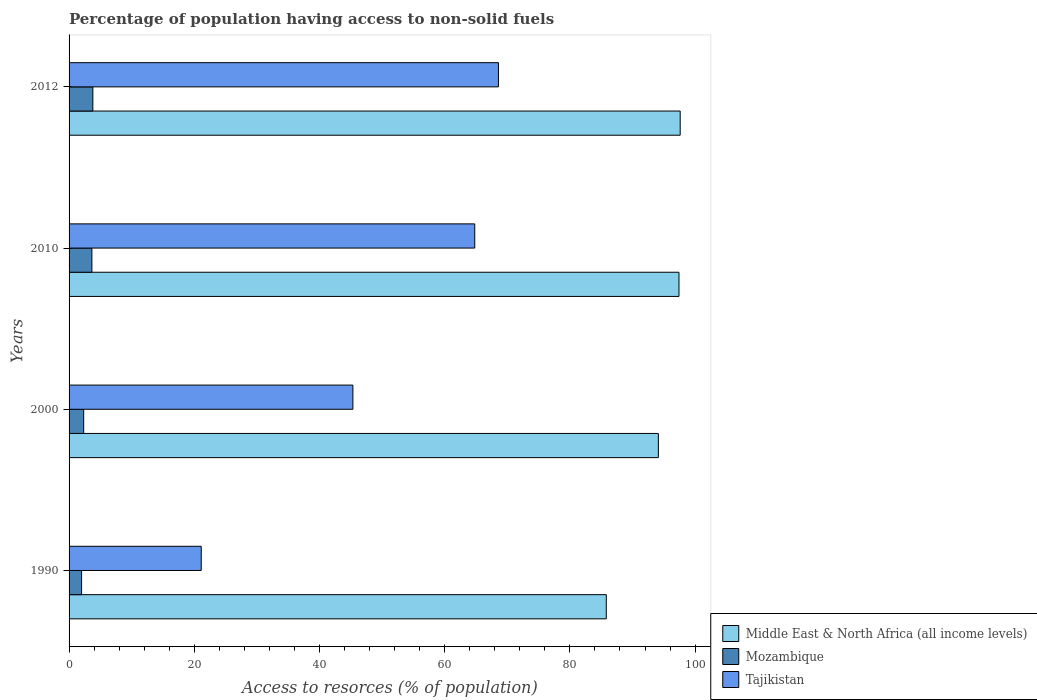How many groups of bars are there?
Ensure brevity in your answer.  4. What is the percentage of population having access to non-solid fuels in Mozambique in 1990?
Ensure brevity in your answer.  2. Across all years, what is the maximum percentage of population having access to non-solid fuels in Mozambique?
Ensure brevity in your answer.  3.8. Across all years, what is the minimum percentage of population having access to non-solid fuels in Mozambique?
Give a very brief answer. 2. What is the total percentage of population having access to non-solid fuels in Tajikistan in the graph?
Your answer should be compact. 199.84. What is the difference between the percentage of population having access to non-solid fuels in Middle East & North Africa (all income levels) in 1990 and that in 2000?
Your answer should be compact. -8.32. What is the difference between the percentage of population having access to non-solid fuels in Tajikistan in 2000 and the percentage of population having access to non-solid fuels in Middle East & North Africa (all income levels) in 2012?
Keep it short and to the point. -52.28. What is the average percentage of population having access to non-solid fuels in Mozambique per year?
Offer a terse response. 2.94. In the year 2010, what is the difference between the percentage of population having access to non-solid fuels in Tajikistan and percentage of population having access to non-solid fuels in Middle East & North Africa (all income levels)?
Make the answer very short. -32.62. What is the ratio of the percentage of population having access to non-solid fuels in Middle East & North Africa (all income levels) in 1990 to that in 2010?
Make the answer very short. 0.88. Is the percentage of population having access to non-solid fuels in Mozambique in 2000 less than that in 2010?
Your response must be concise. Yes. What is the difference between the highest and the second highest percentage of population having access to non-solid fuels in Middle East & North Africa (all income levels)?
Provide a succinct answer. 0.19. What is the difference between the highest and the lowest percentage of population having access to non-solid fuels in Mozambique?
Your response must be concise. 1.8. In how many years, is the percentage of population having access to non-solid fuels in Tajikistan greater than the average percentage of population having access to non-solid fuels in Tajikistan taken over all years?
Provide a short and direct response. 2. What does the 1st bar from the top in 2010 represents?
Your response must be concise. Tajikistan. What does the 3rd bar from the bottom in 1990 represents?
Give a very brief answer. Tajikistan. Is it the case that in every year, the sum of the percentage of population having access to non-solid fuels in Middle East & North Africa (all income levels) and percentage of population having access to non-solid fuels in Tajikistan is greater than the percentage of population having access to non-solid fuels in Mozambique?
Make the answer very short. Yes. How many bars are there?
Provide a succinct answer. 12. How many years are there in the graph?
Your response must be concise. 4. What is the difference between two consecutive major ticks on the X-axis?
Provide a short and direct response. 20. Does the graph contain grids?
Your answer should be very brief. No. Where does the legend appear in the graph?
Provide a short and direct response. Bottom right. How many legend labels are there?
Your response must be concise. 3. What is the title of the graph?
Your answer should be very brief. Percentage of population having access to non-solid fuels. What is the label or title of the X-axis?
Provide a short and direct response. Access to resorces (% of population). What is the Access to resorces (% of population) of Middle East & North Africa (all income levels) in 1990?
Your answer should be compact. 85.81. What is the Access to resorces (% of population) in Mozambique in 1990?
Your response must be concise. 2. What is the Access to resorces (% of population) of Tajikistan in 1990?
Give a very brief answer. 21.11. What is the Access to resorces (% of population) of Middle East & North Africa (all income levels) in 2000?
Give a very brief answer. 94.13. What is the Access to resorces (% of population) of Mozambique in 2000?
Your answer should be very brief. 2.34. What is the Access to resorces (% of population) in Tajikistan in 2000?
Your response must be concise. 45.34. What is the Access to resorces (% of population) of Middle East & North Africa (all income levels) in 2010?
Your answer should be compact. 97.43. What is the Access to resorces (% of population) of Mozambique in 2010?
Your answer should be very brief. 3.65. What is the Access to resorces (% of population) in Tajikistan in 2010?
Keep it short and to the point. 64.8. What is the Access to resorces (% of population) in Middle East & North Africa (all income levels) in 2012?
Keep it short and to the point. 97.62. What is the Access to resorces (% of population) in Mozambique in 2012?
Provide a succinct answer. 3.8. What is the Access to resorces (% of population) in Tajikistan in 2012?
Give a very brief answer. 68.59. Across all years, what is the maximum Access to resorces (% of population) of Middle East & North Africa (all income levels)?
Keep it short and to the point. 97.62. Across all years, what is the maximum Access to resorces (% of population) in Mozambique?
Keep it short and to the point. 3.8. Across all years, what is the maximum Access to resorces (% of population) in Tajikistan?
Keep it short and to the point. 68.59. Across all years, what is the minimum Access to resorces (% of population) in Middle East & North Africa (all income levels)?
Offer a terse response. 85.81. Across all years, what is the minimum Access to resorces (% of population) of Mozambique?
Ensure brevity in your answer.  2. Across all years, what is the minimum Access to resorces (% of population) of Tajikistan?
Offer a very short reply. 21.11. What is the total Access to resorces (% of population) in Middle East & North Africa (all income levels) in the graph?
Keep it short and to the point. 374.99. What is the total Access to resorces (% of population) in Mozambique in the graph?
Provide a short and direct response. 11.78. What is the total Access to resorces (% of population) in Tajikistan in the graph?
Give a very brief answer. 199.84. What is the difference between the Access to resorces (% of population) of Middle East & North Africa (all income levels) in 1990 and that in 2000?
Your response must be concise. -8.32. What is the difference between the Access to resorces (% of population) in Mozambique in 1990 and that in 2000?
Offer a very short reply. -0.34. What is the difference between the Access to resorces (% of population) in Tajikistan in 1990 and that in 2000?
Provide a succinct answer. -24.22. What is the difference between the Access to resorces (% of population) of Middle East & North Africa (all income levels) in 1990 and that in 2010?
Your answer should be compact. -11.61. What is the difference between the Access to resorces (% of population) of Mozambique in 1990 and that in 2010?
Provide a short and direct response. -1.65. What is the difference between the Access to resorces (% of population) of Tajikistan in 1990 and that in 2010?
Your response must be concise. -43.69. What is the difference between the Access to resorces (% of population) in Middle East & North Africa (all income levels) in 1990 and that in 2012?
Your response must be concise. -11.8. What is the difference between the Access to resorces (% of population) in Mozambique in 1990 and that in 2012?
Offer a very short reply. -1.8. What is the difference between the Access to resorces (% of population) in Tajikistan in 1990 and that in 2012?
Offer a very short reply. -47.47. What is the difference between the Access to resorces (% of population) of Middle East & North Africa (all income levels) in 2000 and that in 2010?
Make the answer very short. -3.3. What is the difference between the Access to resorces (% of population) in Mozambique in 2000 and that in 2010?
Give a very brief answer. -1.31. What is the difference between the Access to resorces (% of population) in Tajikistan in 2000 and that in 2010?
Provide a short and direct response. -19.47. What is the difference between the Access to resorces (% of population) in Middle East & North Africa (all income levels) in 2000 and that in 2012?
Make the answer very short. -3.49. What is the difference between the Access to resorces (% of population) in Mozambique in 2000 and that in 2012?
Your answer should be compact. -1.46. What is the difference between the Access to resorces (% of population) of Tajikistan in 2000 and that in 2012?
Your answer should be compact. -23.25. What is the difference between the Access to resorces (% of population) of Middle East & North Africa (all income levels) in 2010 and that in 2012?
Ensure brevity in your answer.  -0.19. What is the difference between the Access to resorces (% of population) of Mozambique in 2010 and that in 2012?
Offer a terse response. -0.15. What is the difference between the Access to resorces (% of population) in Tajikistan in 2010 and that in 2012?
Keep it short and to the point. -3.78. What is the difference between the Access to resorces (% of population) of Middle East & North Africa (all income levels) in 1990 and the Access to resorces (% of population) of Mozambique in 2000?
Offer a very short reply. 83.48. What is the difference between the Access to resorces (% of population) in Middle East & North Africa (all income levels) in 1990 and the Access to resorces (% of population) in Tajikistan in 2000?
Ensure brevity in your answer.  40.48. What is the difference between the Access to resorces (% of population) in Mozambique in 1990 and the Access to resorces (% of population) in Tajikistan in 2000?
Provide a short and direct response. -43.34. What is the difference between the Access to resorces (% of population) in Middle East & North Africa (all income levels) in 1990 and the Access to resorces (% of population) in Mozambique in 2010?
Offer a very short reply. 82.17. What is the difference between the Access to resorces (% of population) of Middle East & North Africa (all income levels) in 1990 and the Access to resorces (% of population) of Tajikistan in 2010?
Provide a short and direct response. 21.01. What is the difference between the Access to resorces (% of population) in Mozambique in 1990 and the Access to resorces (% of population) in Tajikistan in 2010?
Give a very brief answer. -62.8. What is the difference between the Access to resorces (% of population) of Middle East & North Africa (all income levels) in 1990 and the Access to resorces (% of population) of Mozambique in 2012?
Your answer should be compact. 82.02. What is the difference between the Access to resorces (% of population) in Middle East & North Africa (all income levels) in 1990 and the Access to resorces (% of population) in Tajikistan in 2012?
Provide a short and direct response. 17.23. What is the difference between the Access to resorces (% of population) of Mozambique in 1990 and the Access to resorces (% of population) of Tajikistan in 2012?
Offer a very short reply. -66.59. What is the difference between the Access to resorces (% of population) of Middle East & North Africa (all income levels) in 2000 and the Access to resorces (% of population) of Mozambique in 2010?
Your response must be concise. 90.48. What is the difference between the Access to resorces (% of population) in Middle East & North Africa (all income levels) in 2000 and the Access to resorces (% of population) in Tajikistan in 2010?
Offer a very short reply. 29.33. What is the difference between the Access to resorces (% of population) in Mozambique in 2000 and the Access to resorces (% of population) in Tajikistan in 2010?
Your response must be concise. -62.47. What is the difference between the Access to resorces (% of population) of Middle East & North Africa (all income levels) in 2000 and the Access to resorces (% of population) of Mozambique in 2012?
Keep it short and to the point. 90.33. What is the difference between the Access to resorces (% of population) of Middle East & North Africa (all income levels) in 2000 and the Access to resorces (% of population) of Tajikistan in 2012?
Offer a very short reply. 25.54. What is the difference between the Access to resorces (% of population) of Mozambique in 2000 and the Access to resorces (% of population) of Tajikistan in 2012?
Give a very brief answer. -66.25. What is the difference between the Access to resorces (% of population) of Middle East & North Africa (all income levels) in 2010 and the Access to resorces (% of population) of Mozambique in 2012?
Make the answer very short. 93.63. What is the difference between the Access to resorces (% of population) of Middle East & North Africa (all income levels) in 2010 and the Access to resorces (% of population) of Tajikistan in 2012?
Ensure brevity in your answer.  28.84. What is the difference between the Access to resorces (% of population) in Mozambique in 2010 and the Access to resorces (% of population) in Tajikistan in 2012?
Keep it short and to the point. -64.94. What is the average Access to resorces (% of population) of Middle East & North Africa (all income levels) per year?
Offer a very short reply. 93.75. What is the average Access to resorces (% of population) in Mozambique per year?
Give a very brief answer. 2.94. What is the average Access to resorces (% of population) in Tajikistan per year?
Give a very brief answer. 49.96. In the year 1990, what is the difference between the Access to resorces (% of population) in Middle East & North Africa (all income levels) and Access to resorces (% of population) in Mozambique?
Offer a terse response. 83.81. In the year 1990, what is the difference between the Access to resorces (% of population) in Middle East & North Africa (all income levels) and Access to resorces (% of population) in Tajikistan?
Offer a very short reply. 64.7. In the year 1990, what is the difference between the Access to resorces (% of population) in Mozambique and Access to resorces (% of population) in Tajikistan?
Your response must be concise. -19.11. In the year 2000, what is the difference between the Access to resorces (% of population) of Middle East & North Africa (all income levels) and Access to resorces (% of population) of Mozambique?
Your answer should be compact. 91.8. In the year 2000, what is the difference between the Access to resorces (% of population) of Middle East & North Africa (all income levels) and Access to resorces (% of population) of Tajikistan?
Offer a terse response. 48.79. In the year 2000, what is the difference between the Access to resorces (% of population) in Mozambique and Access to resorces (% of population) in Tajikistan?
Keep it short and to the point. -43. In the year 2010, what is the difference between the Access to resorces (% of population) of Middle East & North Africa (all income levels) and Access to resorces (% of population) of Mozambique?
Ensure brevity in your answer.  93.78. In the year 2010, what is the difference between the Access to resorces (% of population) in Middle East & North Africa (all income levels) and Access to resorces (% of population) in Tajikistan?
Provide a short and direct response. 32.62. In the year 2010, what is the difference between the Access to resorces (% of population) of Mozambique and Access to resorces (% of population) of Tajikistan?
Provide a short and direct response. -61.16. In the year 2012, what is the difference between the Access to resorces (% of population) in Middle East & North Africa (all income levels) and Access to resorces (% of population) in Mozambique?
Offer a very short reply. 93.82. In the year 2012, what is the difference between the Access to resorces (% of population) in Middle East & North Africa (all income levels) and Access to resorces (% of population) in Tajikistan?
Ensure brevity in your answer.  29.03. In the year 2012, what is the difference between the Access to resorces (% of population) of Mozambique and Access to resorces (% of population) of Tajikistan?
Make the answer very short. -64.79. What is the ratio of the Access to resorces (% of population) of Middle East & North Africa (all income levels) in 1990 to that in 2000?
Offer a terse response. 0.91. What is the ratio of the Access to resorces (% of population) of Mozambique in 1990 to that in 2000?
Your answer should be compact. 0.86. What is the ratio of the Access to resorces (% of population) of Tajikistan in 1990 to that in 2000?
Keep it short and to the point. 0.47. What is the ratio of the Access to resorces (% of population) in Middle East & North Africa (all income levels) in 1990 to that in 2010?
Offer a very short reply. 0.88. What is the ratio of the Access to resorces (% of population) of Mozambique in 1990 to that in 2010?
Ensure brevity in your answer.  0.55. What is the ratio of the Access to resorces (% of population) of Tajikistan in 1990 to that in 2010?
Ensure brevity in your answer.  0.33. What is the ratio of the Access to resorces (% of population) in Middle East & North Africa (all income levels) in 1990 to that in 2012?
Make the answer very short. 0.88. What is the ratio of the Access to resorces (% of population) in Mozambique in 1990 to that in 2012?
Offer a very short reply. 0.53. What is the ratio of the Access to resorces (% of population) in Tajikistan in 1990 to that in 2012?
Ensure brevity in your answer.  0.31. What is the ratio of the Access to resorces (% of population) in Middle East & North Africa (all income levels) in 2000 to that in 2010?
Your answer should be very brief. 0.97. What is the ratio of the Access to resorces (% of population) of Mozambique in 2000 to that in 2010?
Make the answer very short. 0.64. What is the ratio of the Access to resorces (% of population) in Tajikistan in 2000 to that in 2010?
Keep it short and to the point. 0.7. What is the ratio of the Access to resorces (% of population) of Middle East & North Africa (all income levels) in 2000 to that in 2012?
Make the answer very short. 0.96. What is the ratio of the Access to resorces (% of population) in Mozambique in 2000 to that in 2012?
Keep it short and to the point. 0.61. What is the ratio of the Access to resorces (% of population) in Tajikistan in 2000 to that in 2012?
Provide a succinct answer. 0.66. What is the ratio of the Access to resorces (% of population) in Mozambique in 2010 to that in 2012?
Your answer should be very brief. 0.96. What is the ratio of the Access to resorces (% of population) of Tajikistan in 2010 to that in 2012?
Provide a short and direct response. 0.94. What is the difference between the highest and the second highest Access to resorces (% of population) of Middle East & North Africa (all income levels)?
Make the answer very short. 0.19. What is the difference between the highest and the second highest Access to resorces (% of population) in Mozambique?
Keep it short and to the point. 0.15. What is the difference between the highest and the second highest Access to resorces (% of population) of Tajikistan?
Make the answer very short. 3.78. What is the difference between the highest and the lowest Access to resorces (% of population) of Middle East & North Africa (all income levels)?
Offer a terse response. 11.8. What is the difference between the highest and the lowest Access to resorces (% of population) of Mozambique?
Provide a short and direct response. 1.8. What is the difference between the highest and the lowest Access to resorces (% of population) of Tajikistan?
Offer a very short reply. 47.47. 